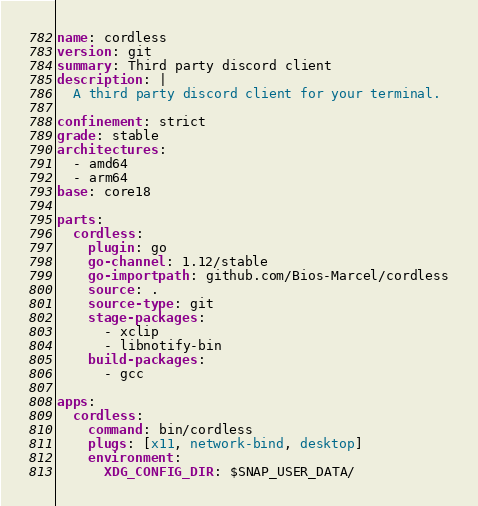Convert code to text. <code><loc_0><loc_0><loc_500><loc_500><_YAML_>name: cordless
version: git
summary: Third party discord client
description: |
  A third party discord client for your terminal.

confinement: strict
grade: stable
architectures: 
  - amd64
  - arm64
base: core18

parts:
  cordless:
    plugin: go
    go-channel: 1.12/stable
    go-importpath: github.com/Bios-Marcel/cordless
    source: .
    source-type: git
    stage-packages:
      - xclip
      - libnotify-bin
    build-packages:
      - gcc
    
apps:
  cordless:
    command: bin/cordless
    plugs: [x11, network-bind, desktop]
    environment:
      XDG_CONFIG_DIR: $SNAP_USER_DATA/</code> 